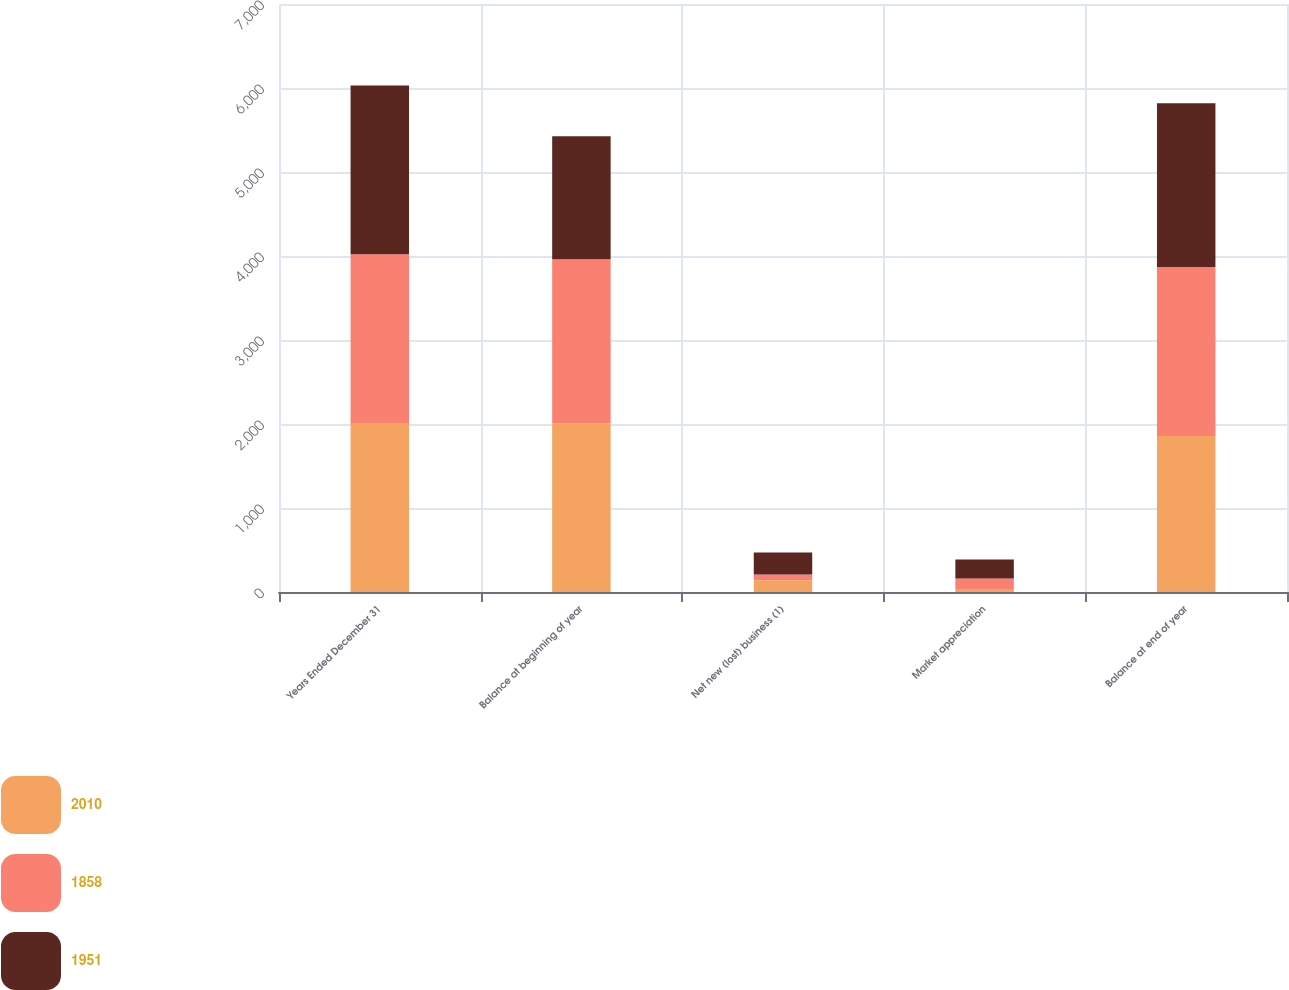<chart> <loc_0><loc_0><loc_500><loc_500><stacked_bar_chart><ecel><fcel>Years Ended December 31<fcel>Balance at beginning of year<fcel>Net new (lost) business (1)<fcel>Market appreciation<fcel>Balance at end of year<nl><fcel>2010<fcel>2011<fcel>2010<fcel>140<fcel>35<fcel>1858<nl><fcel>1858<fcel>2010<fcel>1951<fcel>68<fcel>127<fcel>2010<nl><fcel>1951<fcel>2009<fcel>1466<fcel>261<fcel>224<fcel>1951<nl></chart> 